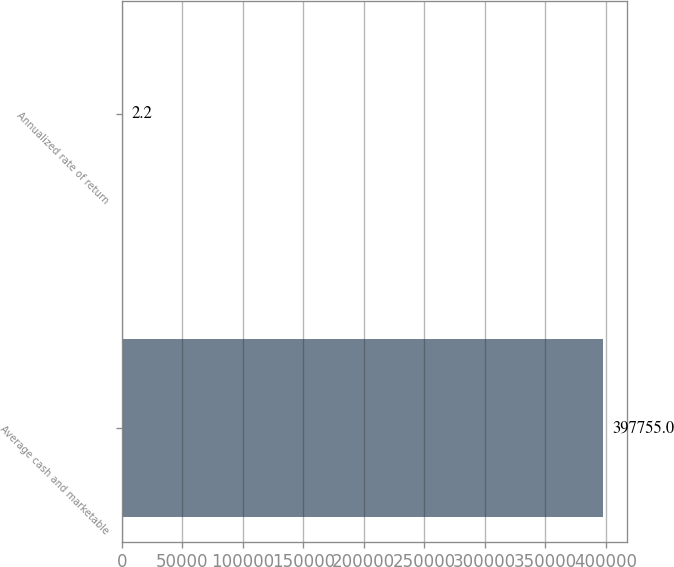Convert chart to OTSL. <chart><loc_0><loc_0><loc_500><loc_500><bar_chart><fcel>Average cash and marketable<fcel>Annualized rate of return<nl><fcel>397755<fcel>2.2<nl></chart> 